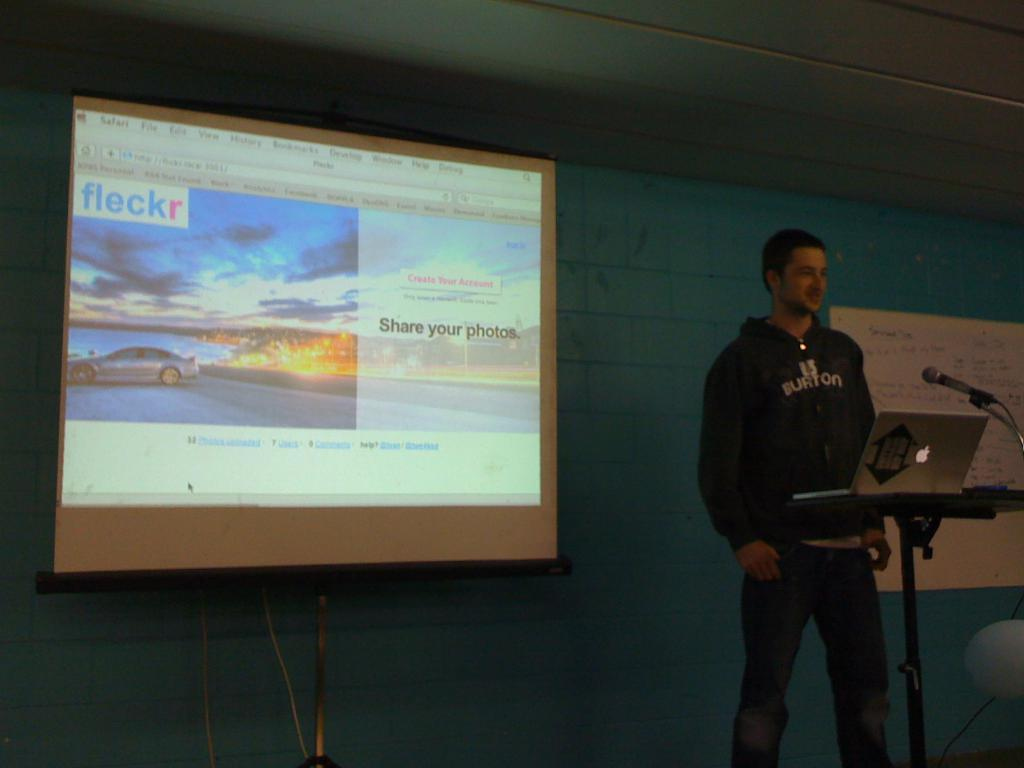Provide a one-sentence caption for the provided image. a man in a dark hoodie giving a presentation with a screen reading FLECKR. 